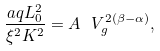<formula> <loc_0><loc_0><loc_500><loc_500>\frac { a q L _ { 0 } ^ { 2 } } { \xi ^ { 2 } K ^ { 2 } } = A \ V _ { g } ^ { 2 ( \beta - \alpha ) } ,</formula> 